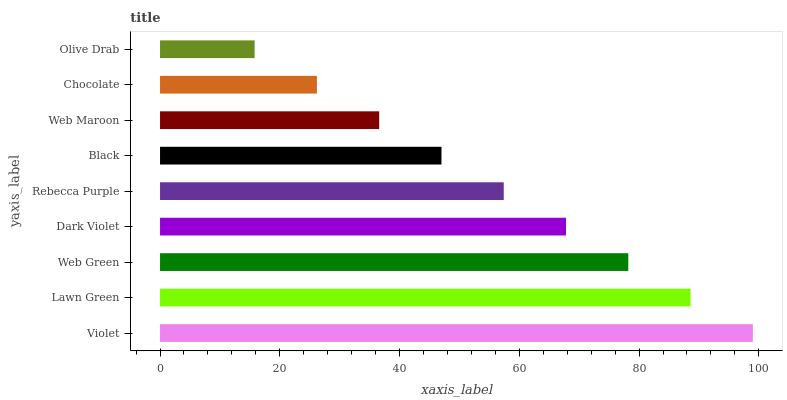Is Olive Drab the minimum?
Answer yes or no. Yes. Is Violet the maximum?
Answer yes or no. Yes. Is Lawn Green the minimum?
Answer yes or no. No. Is Lawn Green the maximum?
Answer yes or no. No. Is Violet greater than Lawn Green?
Answer yes or no. Yes. Is Lawn Green less than Violet?
Answer yes or no. Yes. Is Lawn Green greater than Violet?
Answer yes or no. No. Is Violet less than Lawn Green?
Answer yes or no. No. Is Rebecca Purple the high median?
Answer yes or no. Yes. Is Rebecca Purple the low median?
Answer yes or no. Yes. Is Lawn Green the high median?
Answer yes or no. No. Is Web Maroon the low median?
Answer yes or no. No. 